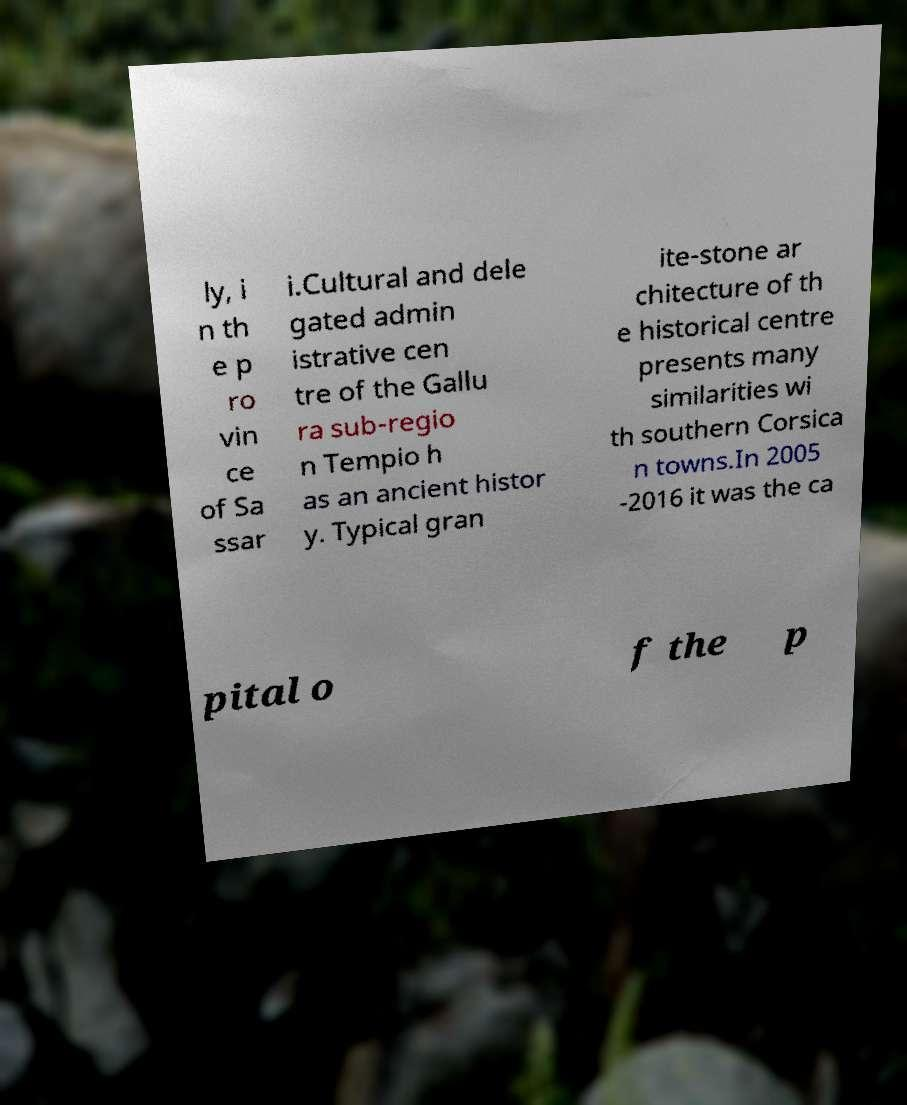Could you extract and type out the text from this image? ly, i n th e p ro vin ce of Sa ssar i.Cultural and dele gated admin istrative cen tre of the Gallu ra sub-regio n Tempio h as an ancient histor y. Typical gran ite-stone ar chitecture of th e historical centre presents many similarities wi th southern Corsica n towns.In 2005 -2016 it was the ca pital o f the p 